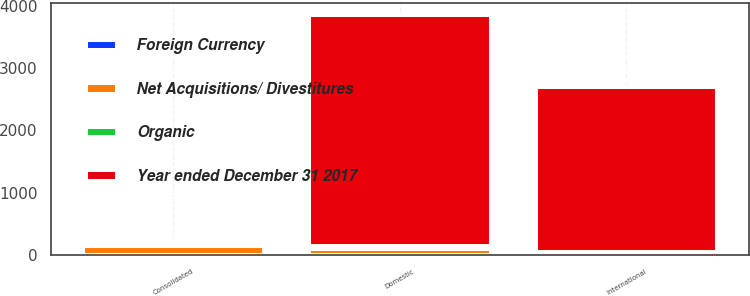Convert chart. <chart><loc_0><loc_0><loc_500><loc_500><stacked_bar_chart><ecel><fcel>Consolidated<fcel>Domestic<fcel>International<nl><fcel>Year ended December 31 2017<fcel>50.4<fcel>3688.7<fcel>2630.7<nl><fcel>Foreign Currency<fcel>6.5<fcel>0<fcel>6.5<nl><fcel>Organic<fcel>67.7<fcel>50.4<fcel>17.3<nl><fcel>Net Acquisitions/ Divestitures<fcel>139.1<fcel>104.8<fcel>34.3<nl></chart> 